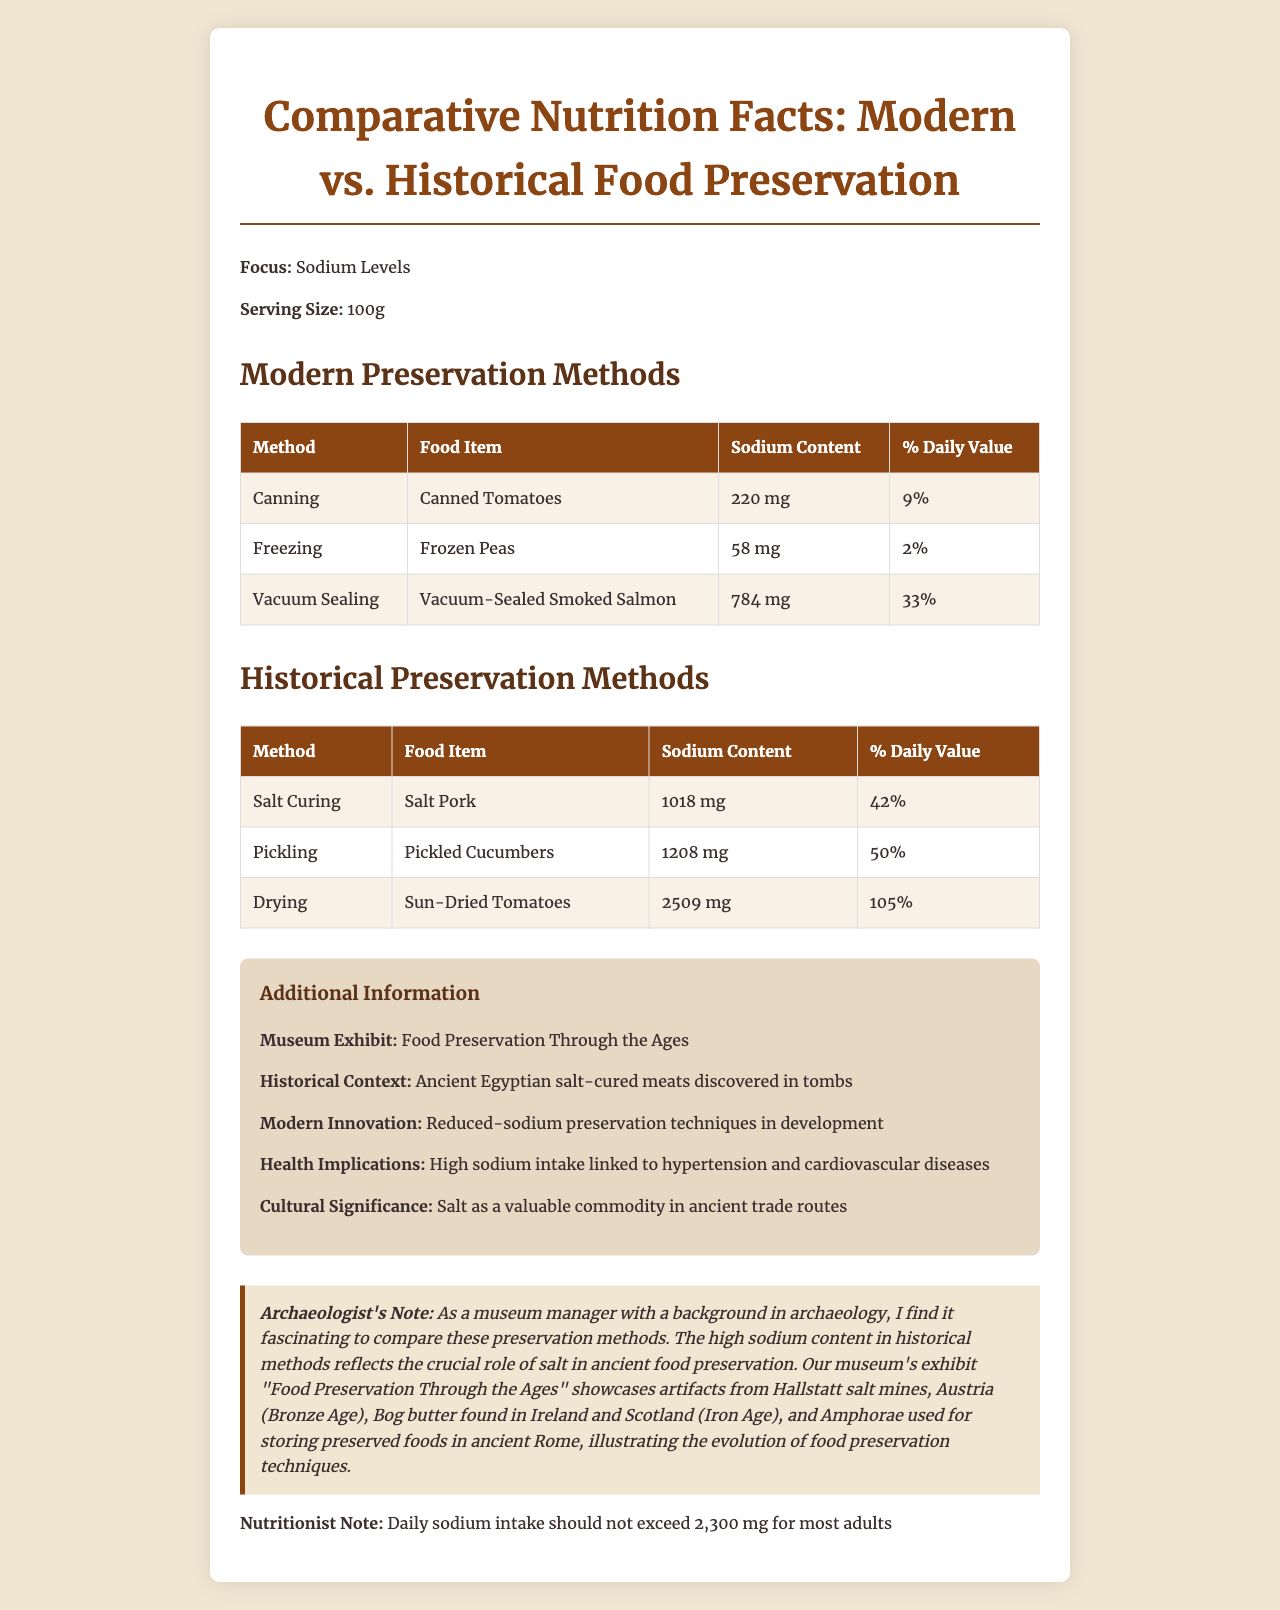what is the main focus of the document? The document explicitly states that the focus is on "Sodium Levels".
Answer: Sodium Levels what is the serving size used for comparison? The document mentions that the serving size for all comparisons is "100g".
Answer: 100g which food item has the highest sodium content in historical preservation methods? The historical preservation method of drying Sun-Dried Tomatoes has the highest sodium content at 2509 mg.
Answer: Sun-Dried Tomatoes What modern preservation method resulted in the highest sodium content? The Vacuum-Sealed Smoked Salmon has the highest sodium content among modern methods, at 784 mg.
Answer: Vacuum-Sealing what does the museum exhibit focus on? The additional information section specifies that the exhibit focuses on "Food Preservation Through the Ages".
Answer: Food Preservation Through the Ages True or False: Canned Tomatoes have a higher sodium content than Frozen Peas. Canned Tomatoes have 220 mg of sodium, while Frozen Peas have only 58 mg of sodium.
Answer: True Which of the following food items has the lowest percentage of daily sodium value? A. Canned Tomatoes B. Frozen Peas C. Vacuum-Sealed Smoked Salmon Frozen Peas have the lowest percentage of daily sodium value at 2%.
Answer: B What is the percent daily value of sodium for Pickled Cucumbers? The sodium content of Pickled Cucumbers has a percent daily value of 50%.
Answer: 50% Summarize the main idea of this document. The document provides a comparative analysis of sodium levels in foods preserved through various methods, both modern and historical. It offers detailed tables with nutrition facts and includes context about the significance of these methods and their health implications, particularly concerning sodium intake. There is also information about museum exhibits and archaeological finds related to food preservation.
Answer: The document compares the sodium levels in foods preserved through modern and historical methods, highlighting the differences in sodium content and their health implications. It also provides additional information about museum exhibits and historical contexts, emphasizing the role of salt in preservation. Where were the ancient salt mines that were discussed? The document mentions "Hallstatt salt mines" in Austria, from the Bronze Age.
Answer: Hallstatt, Austria Which modern preservation method has the highest percentage of daily sodium value, and what is that percentage? A. Canning - 9% B. Freezing - 2% C. Vacuum Sealing - 33% D. Salt Curing - 42% The modern preservation method of Vacuum Sealing has the highest percentage of daily sodium value at 33%.
Answer: C Does the document provide information on modern innovations related to food preservation? The additional information mentions that "Reduced-sodium preservation techniques are in development."
Answer: Yes Which food preservation method used in ancient Rome was mentioned? The document describes Amphorae as vessels used for storing preserved foods in ancient Rome.
Answer: Amphorae used for storing preserved foods Which food item mentioned has the highest sodium content among all listed methods? A. Salt Pork B. Pickled Cucumbers C. Sun-Dried Tomatoes Sun-Dried Tomatoes have the highest sodium content among all listed methods, with 2509 mg.
Answer: C Is the daily sodium intake recommendation for most adults mentioned in the document? The nutritionist note specifies that daily sodium intake should not exceed 2,300 mg for most adults.
Answer: Yes Can the exact year of the discovery of ancient Egyptian salt-cured meats in tombs be determined from this document? The document mentions the historical context but does not provide an exact year for the discovery of ancient Egyptian salt-cured meats in tombs.
Answer: Cannot be determined 